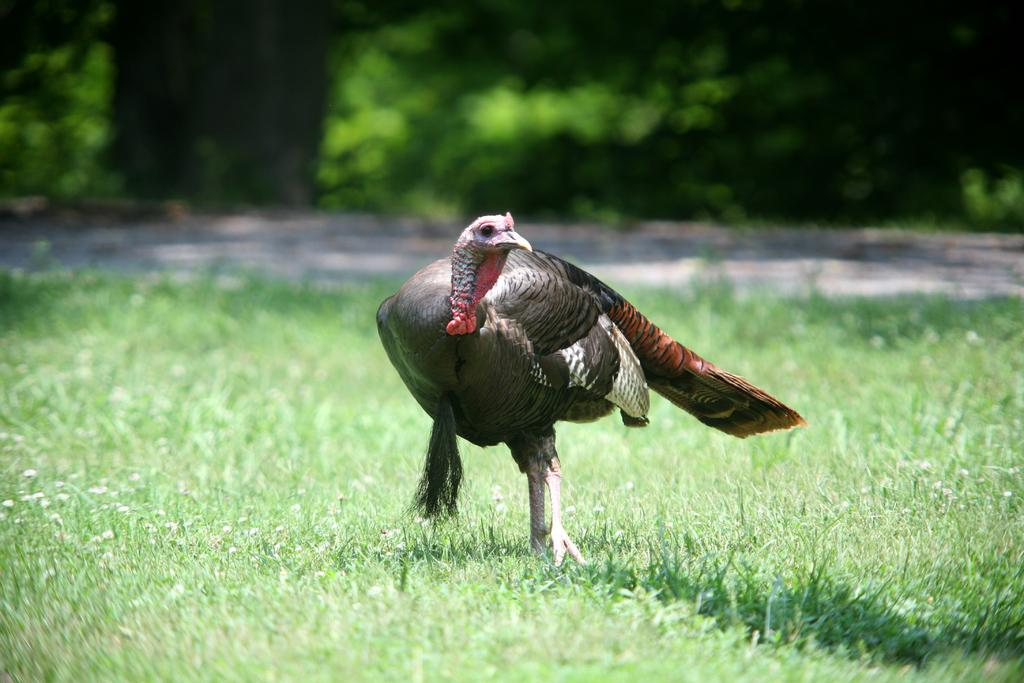What type of animal is in the image? There is a wild turkey in the image. Where is the wild turkey located? The wild turkey is on the ground. What can be seen in the background of the image? There are trees in the background of the image. How many books are stacked next to the wild turkey in the image? There are no books present in the image; it features a wild turkey on the ground with trees in the background. 